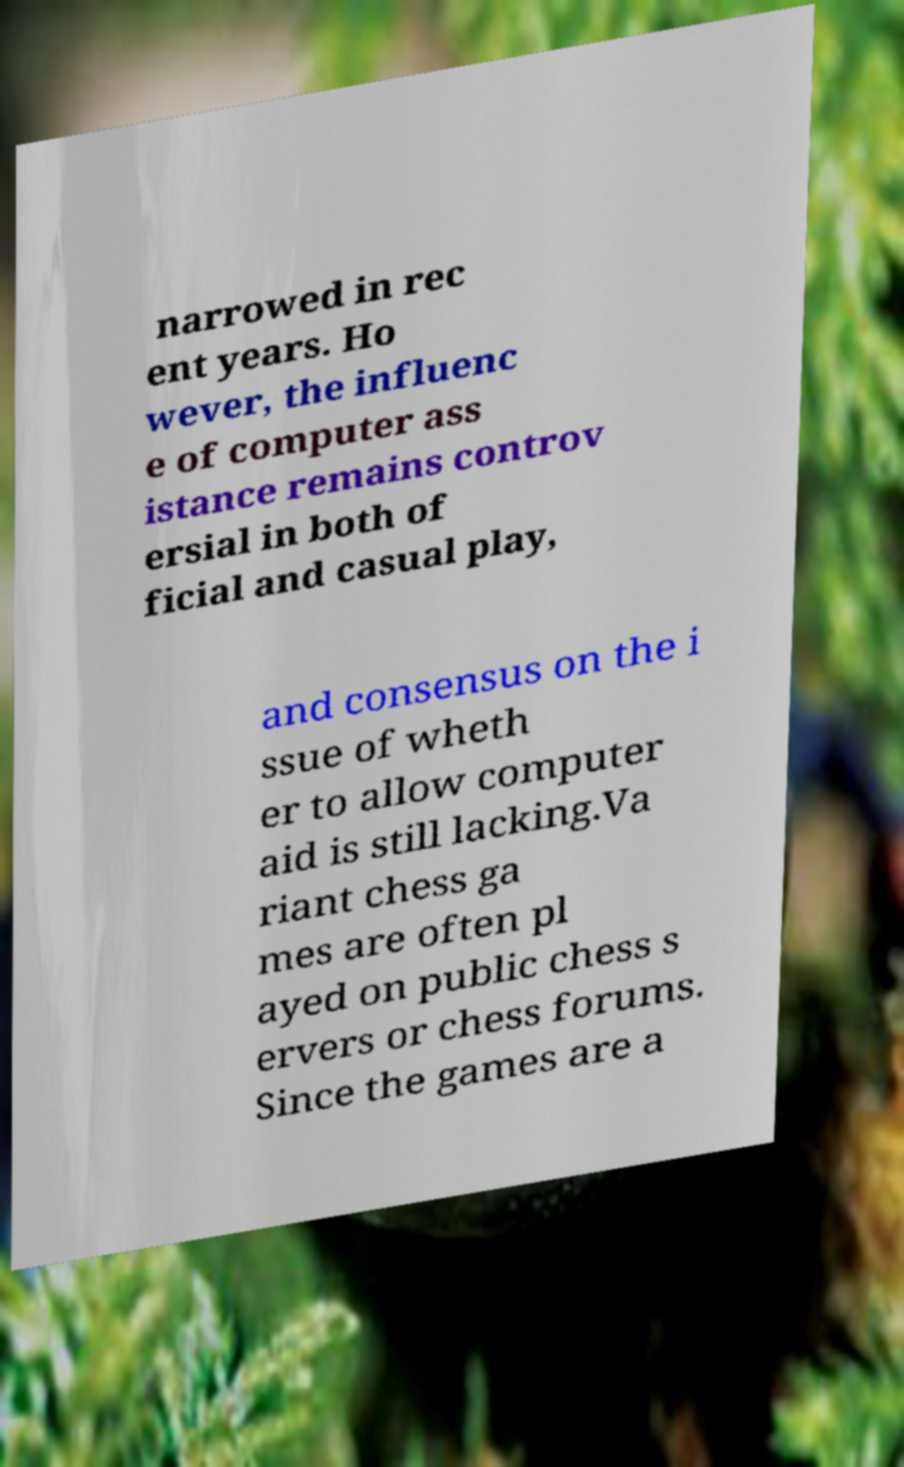Can you read and provide the text displayed in the image?This photo seems to have some interesting text. Can you extract and type it out for me? narrowed in rec ent years. Ho wever, the influenc e of computer ass istance remains controv ersial in both of ficial and casual play, and consensus on the i ssue of wheth er to allow computer aid is still lacking.Va riant chess ga mes are often pl ayed on public chess s ervers or chess forums. Since the games are a 